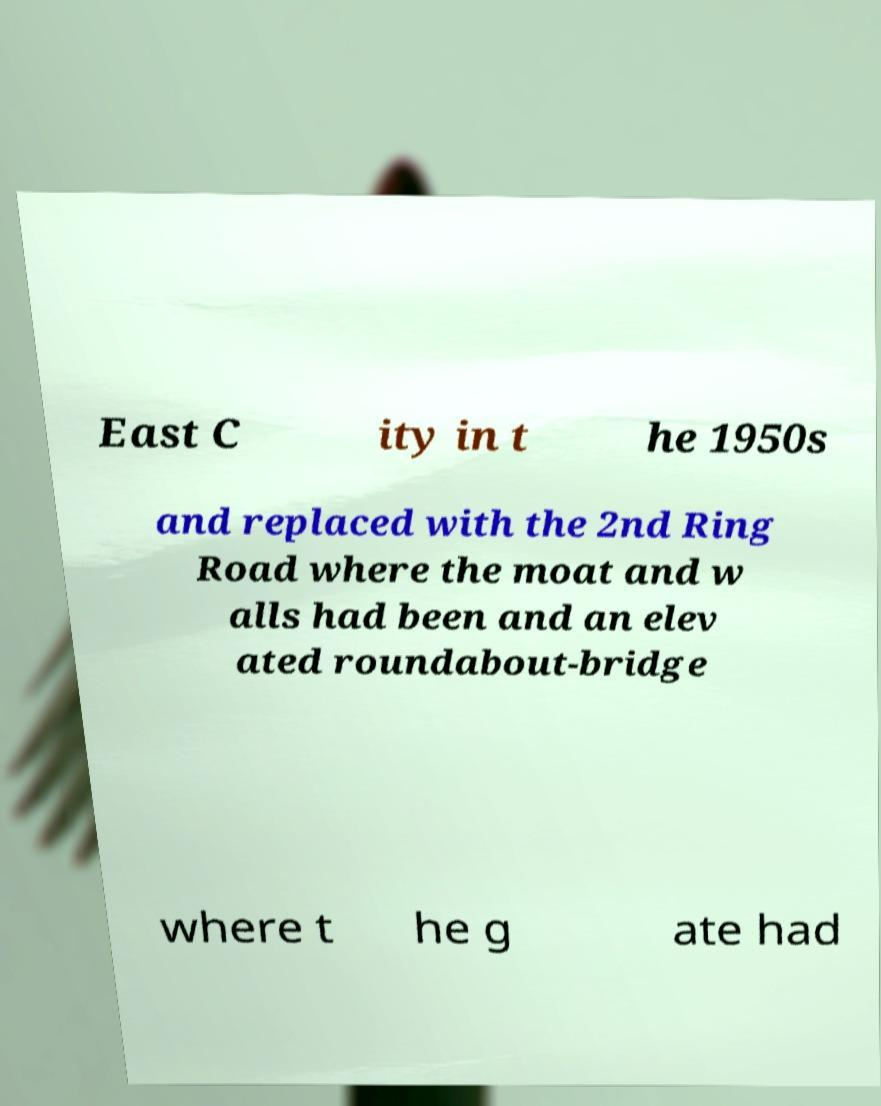There's text embedded in this image that I need extracted. Can you transcribe it verbatim? East C ity in t he 1950s and replaced with the 2nd Ring Road where the moat and w alls had been and an elev ated roundabout-bridge where t he g ate had 